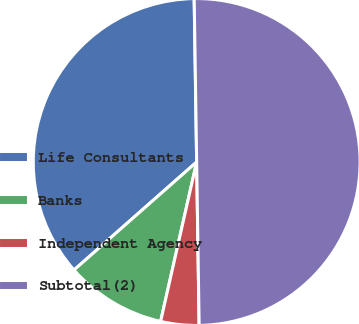<chart> <loc_0><loc_0><loc_500><loc_500><pie_chart><fcel>Life Consultants<fcel>Banks<fcel>Independent Agency<fcel>Subtotal(2)<nl><fcel>36.25%<fcel>9.97%<fcel>3.78%<fcel>50.0%<nl></chart> 